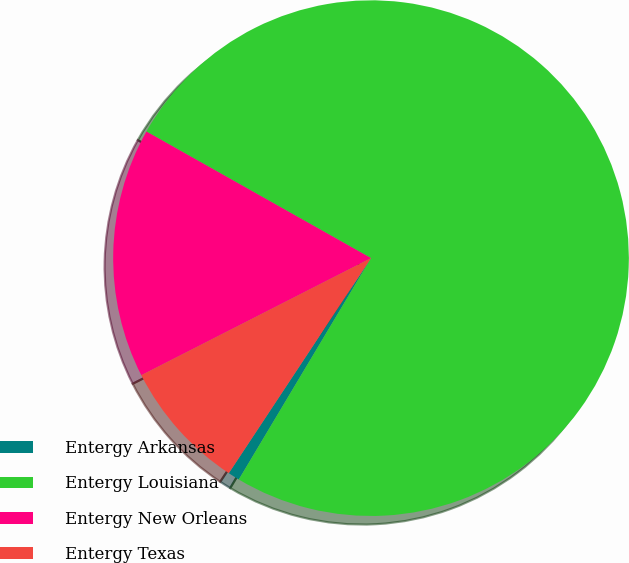Convert chart to OTSL. <chart><loc_0><loc_0><loc_500><loc_500><pie_chart><fcel>Entergy Arkansas<fcel>Entergy Louisiana<fcel>Entergy New Orleans<fcel>Entergy Texas<nl><fcel>0.73%<fcel>75.4%<fcel>15.67%<fcel>8.2%<nl></chart> 